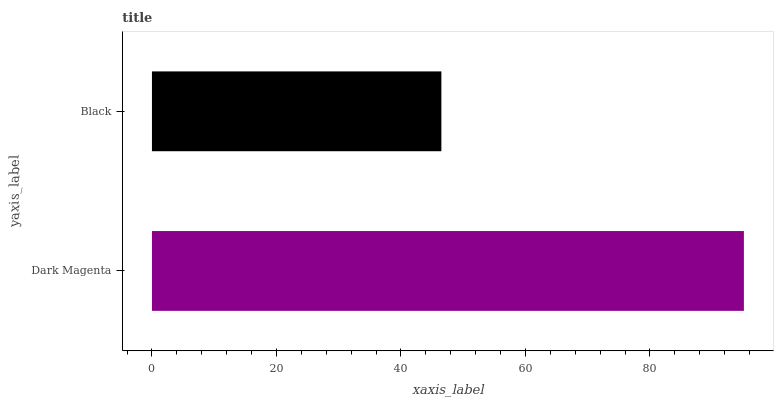Is Black the minimum?
Answer yes or no. Yes. Is Dark Magenta the maximum?
Answer yes or no. Yes. Is Black the maximum?
Answer yes or no. No. Is Dark Magenta greater than Black?
Answer yes or no. Yes. Is Black less than Dark Magenta?
Answer yes or no. Yes. Is Black greater than Dark Magenta?
Answer yes or no. No. Is Dark Magenta less than Black?
Answer yes or no. No. Is Dark Magenta the high median?
Answer yes or no. Yes. Is Black the low median?
Answer yes or no. Yes. Is Black the high median?
Answer yes or no. No. Is Dark Magenta the low median?
Answer yes or no. No. 